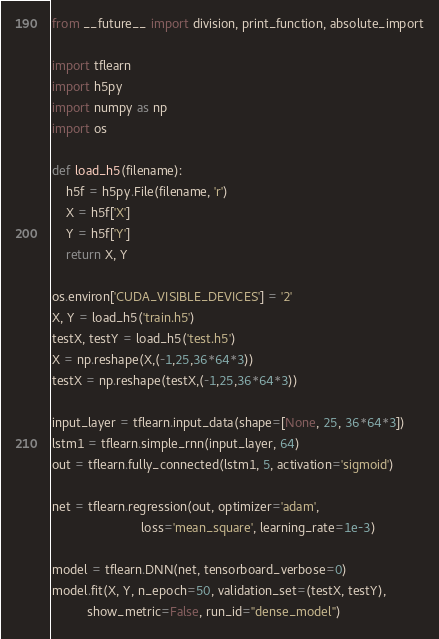<code> <loc_0><loc_0><loc_500><loc_500><_Python_>from __future__ import division, print_function, absolute_import

import tflearn
import h5py
import numpy as np
import os

def load_h5(filename):
    h5f = h5py.File(filename, 'r')
    X = h5f['X']
    Y = h5f['Y']
    return X, Y

os.environ['CUDA_VISIBLE_DEVICES'] = '2'
X, Y = load_h5('train.h5')
testX, testY = load_h5('test.h5')
X = np.reshape(X,(-1,25,36*64*3))
testX = np.reshape(testX,(-1,25,36*64*3))

input_layer = tflearn.input_data(shape=[None, 25, 36*64*3])
lstm1 = tflearn.simple_rnn(input_layer, 64)
out = tflearn.fully_connected(lstm1, 5, activation='sigmoid')

net = tflearn.regression(out, optimizer='adam',
                         loss='mean_square', learning_rate=1e-3)

model = tflearn.DNN(net, tensorboard_verbose=0)
model.fit(X, Y, n_epoch=50, validation_set=(testX, testY),
          show_metric=False, run_id="dense_model")
</code> 